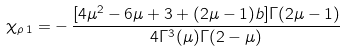<formula> <loc_0><loc_0><loc_500><loc_500>\chi _ { \rho \, 1 } = - \, \frac { [ 4 \mu ^ { 2 } - 6 \mu + 3 + ( 2 \mu - 1 ) b ] \Gamma ( 2 \mu - 1 ) } { 4 \Gamma ^ { 3 } ( \mu ) \Gamma ( 2 - \mu ) }</formula> 